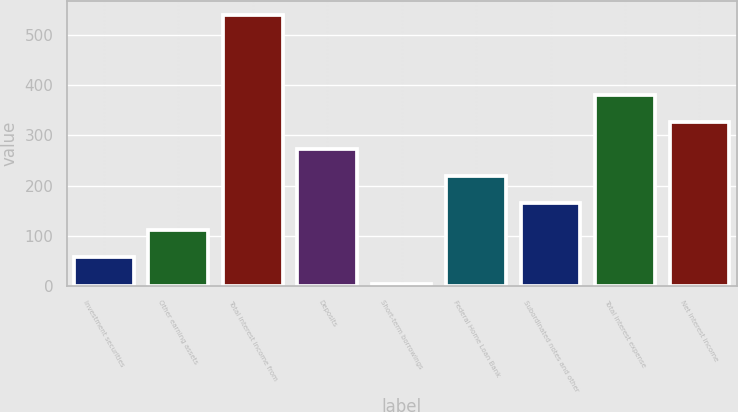Convert chart to OTSL. <chart><loc_0><loc_0><loc_500><loc_500><bar_chart><fcel>Investment securities<fcel>Other earning assets<fcel>Total interest income from<fcel>Deposits<fcel>Short-term borrowings<fcel>Federal Home Loan Bank<fcel>Subordinated notes and other<fcel>Total interest expense<fcel>Net interest income<nl><fcel>58.67<fcel>112.24<fcel>540.8<fcel>272.95<fcel>5.1<fcel>219.38<fcel>165.81<fcel>380.09<fcel>326.52<nl></chart> 